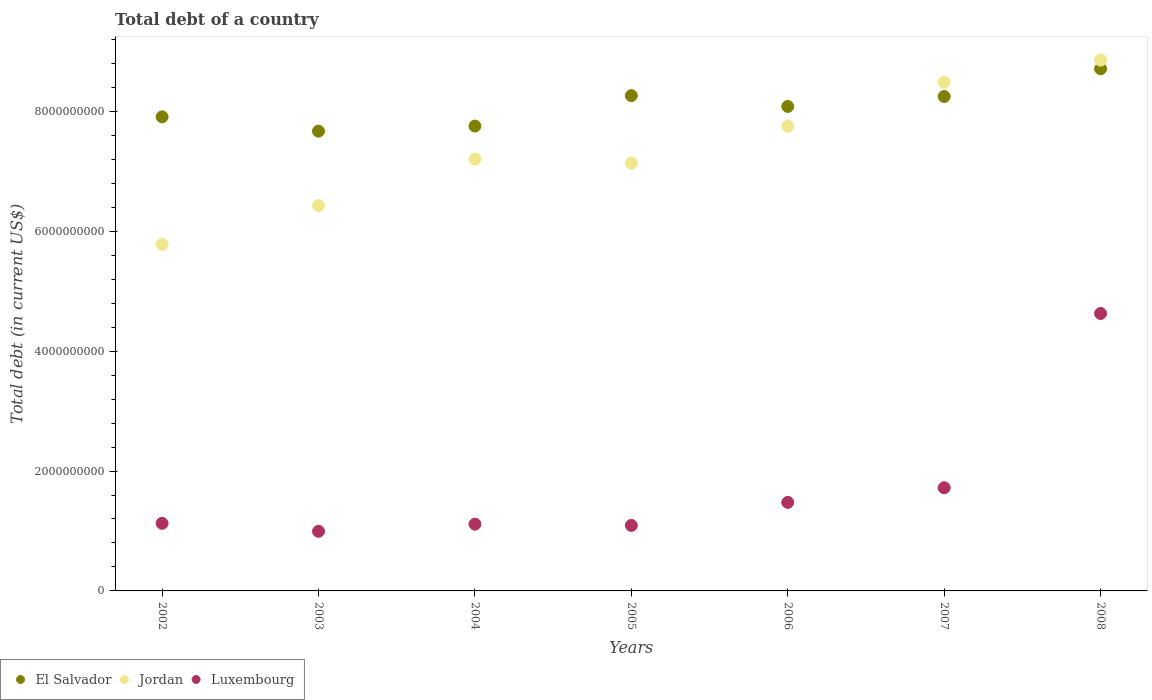How many different coloured dotlines are there?
Keep it short and to the point. 3. Is the number of dotlines equal to the number of legend labels?
Your answer should be compact. Yes. What is the debt in Jordan in 2005?
Offer a terse response. 7.14e+09. Across all years, what is the maximum debt in Jordan?
Give a very brief answer. 8.85e+09. Across all years, what is the minimum debt in Jordan?
Ensure brevity in your answer.  5.78e+09. In which year was the debt in Luxembourg minimum?
Give a very brief answer. 2003. What is the total debt in Jordan in the graph?
Provide a succinct answer. 5.16e+1. What is the difference between the debt in Jordan in 2002 and that in 2005?
Your response must be concise. -1.36e+09. What is the difference between the debt in Luxembourg in 2002 and the debt in Jordan in 2007?
Give a very brief answer. -7.36e+09. What is the average debt in Luxembourg per year?
Offer a terse response. 1.74e+09. In the year 2006, what is the difference between the debt in Luxembourg and debt in El Salvador?
Make the answer very short. -6.61e+09. In how many years, is the debt in Jordan greater than 6000000000 US$?
Give a very brief answer. 6. What is the ratio of the debt in El Salvador in 2005 to that in 2006?
Keep it short and to the point. 1.02. What is the difference between the highest and the second highest debt in Luxembourg?
Make the answer very short. 2.91e+09. What is the difference between the highest and the lowest debt in Jordan?
Give a very brief answer. 3.07e+09. In how many years, is the debt in Jordan greater than the average debt in Jordan taken over all years?
Give a very brief answer. 3. Is it the case that in every year, the sum of the debt in El Salvador and debt in Luxembourg  is greater than the debt in Jordan?
Give a very brief answer. Yes. Does the debt in El Salvador monotonically increase over the years?
Ensure brevity in your answer.  No. Is the debt in El Salvador strictly less than the debt in Jordan over the years?
Your answer should be compact. No. What is the difference between two consecutive major ticks on the Y-axis?
Your answer should be compact. 2.00e+09. Are the values on the major ticks of Y-axis written in scientific E-notation?
Your answer should be very brief. No. Does the graph contain any zero values?
Offer a terse response. No. Does the graph contain grids?
Your response must be concise. No. Where does the legend appear in the graph?
Your answer should be compact. Bottom left. How are the legend labels stacked?
Keep it short and to the point. Horizontal. What is the title of the graph?
Provide a succinct answer. Total debt of a country. What is the label or title of the Y-axis?
Offer a terse response. Total debt (in current US$). What is the Total debt (in current US$) in El Salvador in 2002?
Make the answer very short. 7.91e+09. What is the Total debt (in current US$) of Jordan in 2002?
Offer a very short reply. 5.78e+09. What is the Total debt (in current US$) in Luxembourg in 2002?
Provide a short and direct response. 1.13e+09. What is the Total debt (in current US$) in El Salvador in 2003?
Your answer should be very brief. 7.67e+09. What is the Total debt (in current US$) in Jordan in 2003?
Your response must be concise. 6.43e+09. What is the Total debt (in current US$) of Luxembourg in 2003?
Offer a terse response. 9.94e+08. What is the Total debt (in current US$) of El Salvador in 2004?
Provide a succinct answer. 7.75e+09. What is the Total debt (in current US$) of Jordan in 2004?
Offer a terse response. 7.20e+09. What is the Total debt (in current US$) of Luxembourg in 2004?
Your answer should be very brief. 1.11e+09. What is the Total debt (in current US$) in El Salvador in 2005?
Provide a short and direct response. 8.26e+09. What is the Total debt (in current US$) in Jordan in 2005?
Your response must be concise. 7.14e+09. What is the Total debt (in current US$) of Luxembourg in 2005?
Make the answer very short. 1.09e+09. What is the Total debt (in current US$) in El Salvador in 2006?
Offer a very short reply. 8.08e+09. What is the Total debt (in current US$) of Jordan in 2006?
Your answer should be compact. 7.75e+09. What is the Total debt (in current US$) in Luxembourg in 2006?
Keep it short and to the point. 1.48e+09. What is the Total debt (in current US$) of El Salvador in 2007?
Ensure brevity in your answer.  8.25e+09. What is the Total debt (in current US$) in Jordan in 2007?
Ensure brevity in your answer.  8.49e+09. What is the Total debt (in current US$) in Luxembourg in 2007?
Make the answer very short. 1.72e+09. What is the Total debt (in current US$) in El Salvador in 2008?
Your response must be concise. 8.71e+09. What is the Total debt (in current US$) in Jordan in 2008?
Provide a succinct answer. 8.85e+09. What is the Total debt (in current US$) in Luxembourg in 2008?
Give a very brief answer. 4.63e+09. Across all years, what is the maximum Total debt (in current US$) of El Salvador?
Provide a short and direct response. 8.71e+09. Across all years, what is the maximum Total debt (in current US$) of Jordan?
Offer a terse response. 8.85e+09. Across all years, what is the maximum Total debt (in current US$) of Luxembourg?
Make the answer very short. 4.63e+09. Across all years, what is the minimum Total debt (in current US$) in El Salvador?
Ensure brevity in your answer.  7.67e+09. Across all years, what is the minimum Total debt (in current US$) in Jordan?
Offer a terse response. 5.78e+09. Across all years, what is the minimum Total debt (in current US$) of Luxembourg?
Ensure brevity in your answer.  9.94e+08. What is the total Total debt (in current US$) of El Salvador in the graph?
Offer a very short reply. 5.66e+1. What is the total Total debt (in current US$) of Jordan in the graph?
Provide a succinct answer. 5.16e+1. What is the total Total debt (in current US$) in Luxembourg in the graph?
Offer a terse response. 1.22e+1. What is the difference between the Total debt (in current US$) in El Salvador in 2002 and that in 2003?
Your answer should be compact. 2.39e+08. What is the difference between the Total debt (in current US$) of Jordan in 2002 and that in 2003?
Your answer should be compact. -6.48e+08. What is the difference between the Total debt (in current US$) in Luxembourg in 2002 and that in 2003?
Offer a very short reply. 1.33e+08. What is the difference between the Total debt (in current US$) in El Salvador in 2002 and that in 2004?
Keep it short and to the point. 1.54e+08. What is the difference between the Total debt (in current US$) of Jordan in 2002 and that in 2004?
Provide a short and direct response. -1.42e+09. What is the difference between the Total debt (in current US$) of Luxembourg in 2002 and that in 2004?
Keep it short and to the point. 1.42e+07. What is the difference between the Total debt (in current US$) of El Salvador in 2002 and that in 2005?
Make the answer very short. -3.54e+08. What is the difference between the Total debt (in current US$) in Jordan in 2002 and that in 2005?
Make the answer very short. -1.36e+09. What is the difference between the Total debt (in current US$) in Luxembourg in 2002 and that in 2005?
Offer a terse response. 3.49e+07. What is the difference between the Total debt (in current US$) in El Salvador in 2002 and that in 2006?
Offer a terse response. -1.74e+08. What is the difference between the Total debt (in current US$) of Jordan in 2002 and that in 2006?
Your answer should be compact. -1.97e+09. What is the difference between the Total debt (in current US$) in Luxembourg in 2002 and that in 2006?
Provide a succinct answer. -3.49e+08. What is the difference between the Total debt (in current US$) of El Salvador in 2002 and that in 2007?
Provide a short and direct response. -3.39e+08. What is the difference between the Total debt (in current US$) in Jordan in 2002 and that in 2007?
Your answer should be very brief. -2.71e+09. What is the difference between the Total debt (in current US$) of Luxembourg in 2002 and that in 2007?
Ensure brevity in your answer.  -5.94e+08. What is the difference between the Total debt (in current US$) in El Salvador in 2002 and that in 2008?
Your answer should be very brief. -8.02e+08. What is the difference between the Total debt (in current US$) in Jordan in 2002 and that in 2008?
Your response must be concise. -3.07e+09. What is the difference between the Total debt (in current US$) in Luxembourg in 2002 and that in 2008?
Provide a succinct answer. -3.50e+09. What is the difference between the Total debt (in current US$) in El Salvador in 2003 and that in 2004?
Offer a very short reply. -8.49e+07. What is the difference between the Total debt (in current US$) of Jordan in 2003 and that in 2004?
Keep it short and to the point. -7.75e+08. What is the difference between the Total debt (in current US$) in Luxembourg in 2003 and that in 2004?
Keep it short and to the point. -1.19e+08. What is the difference between the Total debt (in current US$) in El Salvador in 2003 and that in 2005?
Ensure brevity in your answer.  -5.93e+08. What is the difference between the Total debt (in current US$) of Jordan in 2003 and that in 2005?
Your answer should be very brief. -7.08e+08. What is the difference between the Total debt (in current US$) of Luxembourg in 2003 and that in 2005?
Provide a succinct answer. -9.85e+07. What is the difference between the Total debt (in current US$) in El Salvador in 2003 and that in 2006?
Your answer should be very brief. -4.12e+08. What is the difference between the Total debt (in current US$) in Jordan in 2003 and that in 2006?
Your response must be concise. -1.33e+09. What is the difference between the Total debt (in current US$) in Luxembourg in 2003 and that in 2006?
Your answer should be very brief. -4.82e+08. What is the difference between the Total debt (in current US$) in El Salvador in 2003 and that in 2007?
Make the answer very short. -5.78e+08. What is the difference between the Total debt (in current US$) of Jordan in 2003 and that in 2007?
Offer a terse response. -2.06e+09. What is the difference between the Total debt (in current US$) of Luxembourg in 2003 and that in 2007?
Your response must be concise. -7.27e+08. What is the difference between the Total debt (in current US$) of El Salvador in 2003 and that in 2008?
Provide a short and direct response. -1.04e+09. What is the difference between the Total debt (in current US$) in Jordan in 2003 and that in 2008?
Your answer should be compact. -2.43e+09. What is the difference between the Total debt (in current US$) in Luxembourg in 2003 and that in 2008?
Make the answer very short. -3.63e+09. What is the difference between the Total debt (in current US$) of El Salvador in 2004 and that in 2005?
Offer a very short reply. -5.08e+08. What is the difference between the Total debt (in current US$) in Jordan in 2004 and that in 2005?
Your response must be concise. 6.67e+07. What is the difference between the Total debt (in current US$) of Luxembourg in 2004 and that in 2005?
Your answer should be very brief. 2.07e+07. What is the difference between the Total debt (in current US$) in El Salvador in 2004 and that in 2006?
Make the answer very short. -3.27e+08. What is the difference between the Total debt (in current US$) of Jordan in 2004 and that in 2006?
Offer a terse response. -5.50e+08. What is the difference between the Total debt (in current US$) in Luxembourg in 2004 and that in 2006?
Make the answer very short. -3.63e+08. What is the difference between the Total debt (in current US$) of El Salvador in 2004 and that in 2007?
Ensure brevity in your answer.  -4.93e+08. What is the difference between the Total debt (in current US$) in Jordan in 2004 and that in 2007?
Offer a very short reply. -1.28e+09. What is the difference between the Total debt (in current US$) of Luxembourg in 2004 and that in 2007?
Your response must be concise. -6.08e+08. What is the difference between the Total debt (in current US$) of El Salvador in 2004 and that in 2008?
Offer a very short reply. -9.56e+08. What is the difference between the Total debt (in current US$) in Jordan in 2004 and that in 2008?
Keep it short and to the point. -1.65e+09. What is the difference between the Total debt (in current US$) of Luxembourg in 2004 and that in 2008?
Your response must be concise. -3.51e+09. What is the difference between the Total debt (in current US$) in El Salvador in 2005 and that in 2006?
Your answer should be compact. 1.81e+08. What is the difference between the Total debt (in current US$) in Jordan in 2005 and that in 2006?
Your response must be concise. -6.17e+08. What is the difference between the Total debt (in current US$) in Luxembourg in 2005 and that in 2006?
Provide a short and direct response. -3.84e+08. What is the difference between the Total debt (in current US$) in El Salvador in 2005 and that in 2007?
Offer a terse response. 1.49e+07. What is the difference between the Total debt (in current US$) in Jordan in 2005 and that in 2007?
Give a very brief answer. -1.35e+09. What is the difference between the Total debt (in current US$) in Luxembourg in 2005 and that in 2007?
Offer a terse response. -6.28e+08. What is the difference between the Total debt (in current US$) of El Salvador in 2005 and that in 2008?
Keep it short and to the point. -4.48e+08. What is the difference between the Total debt (in current US$) of Jordan in 2005 and that in 2008?
Ensure brevity in your answer.  -1.72e+09. What is the difference between the Total debt (in current US$) of Luxembourg in 2005 and that in 2008?
Your response must be concise. -3.54e+09. What is the difference between the Total debt (in current US$) in El Salvador in 2006 and that in 2007?
Offer a very short reply. -1.66e+08. What is the difference between the Total debt (in current US$) in Jordan in 2006 and that in 2007?
Offer a very short reply. -7.34e+08. What is the difference between the Total debt (in current US$) of Luxembourg in 2006 and that in 2007?
Offer a terse response. -2.44e+08. What is the difference between the Total debt (in current US$) in El Salvador in 2006 and that in 2008?
Provide a succinct answer. -6.29e+08. What is the difference between the Total debt (in current US$) in Jordan in 2006 and that in 2008?
Provide a succinct answer. -1.10e+09. What is the difference between the Total debt (in current US$) of Luxembourg in 2006 and that in 2008?
Your answer should be compact. -3.15e+09. What is the difference between the Total debt (in current US$) of El Salvador in 2007 and that in 2008?
Ensure brevity in your answer.  -4.63e+08. What is the difference between the Total debt (in current US$) of Jordan in 2007 and that in 2008?
Your answer should be compact. -3.68e+08. What is the difference between the Total debt (in current US$) in Luxembourg in 2007 and that in 2008?
Offer a terse response. -2.91e+09. What is the difference between the Total debt (in current US$) of El Salvador in 2002 and the Total debt (in current US$) of Jordan in 2003?
Ensure brevity in your answer.  1.48e+09. What is the difference between the Total debt (in current US$) of El Salvador in 2002 and the Total debt (in current US$) of Luxembourg in 2003?
Make the answer very short. 6.91e+09. What is the difference between the Total debt (in current US$) in Jordan in 2002 and the Total debt (in current US$) in Luxembourg in 2003?
Give a very brief answer. 4.79e+09. What is the difference between the Total debt (in current US$) of El Salvador in 2002 and the Total debt (in current US$) of Jordan in 2004?
Offer a very short reply. 7.06e+08. What is the difference between the Total debt (in current US$) in El Salvador in 2002 and the Total debt (in current US$) in Luxembourg in 2004?
Offer a terse response. 6.79e+09. What is the difference between the Total debt (in current US$) of Jordan in 2002 and the Total debt (in current US$) of Luxembourg in 2004?
Your answer should be compact. 4.67e+09. What is the difference between the Total debt (in current US$) of El Salvador in 2002 and the Total debt (in current US$) of Jordan in 2005?
Keep it short and to the point. 7.72e+08. What is the difference between the Total debt (in current US$) in El Salvador in 2002 and the Total debt (in current US$) in Luxembourg in 2005?
Your answer should be very brief. 6.82e+09. What is the difference between the Total debt (in current US$) in Jordan in 2002 and the Total debt (in current US$) in Luxembourg in 2005?
Ensure brevity in your answer.  4.69e+09. What is the difference between the Total debt (in current US$) of El Salvador in 2002 and the Total debt (in current US$) of Jordan in 2006?
Provide a succinct answer. 1.55e+08. What is the difference between the Total debt (in current US$) in El Salvador in 2002 and the Total debt (in current US$) in Luxembourg in 2006?
Keep it short and to the point. 6.43e+09. What is the difference between the Total debt (in current US$) of Jordan in 2002 and the Total debt (in current US$) of Luxembourg in 2006?
Give a very brief answer. 4.30e+09. What is the difference between the Total debt (in current US$) in El Salvador in 2002 and the Total debt (in current US$) in Jordan in 2007?
Offer a very short reply. -5.79e+08. What is the difference between the Total debt (in current US$) in El Salvador in 2002 and the Total debt (in current US$) in Luxembourg in 2007?
Offer a very short reply. 6.19e+09. What is the difference between the Total debt (in current US$) in Jordan in 2002 and the Total debt (in current US$) in Luxembourg in 2007?
Offer a terse response. 4.06e+09. What is the difference between the Total debt (in current US$) of El Salvador in 2002 and the Total debt (in current US$) of Jordan in 2008?
Your answer should be very brief. -9.46e+08. What is the difference between the Total debt (in current US$) of El Salvador in 2002 and the Total debt (in current US$) of Luxembourg in 2008?
Offer a very short reply. 3.28e+09. What is the difference between the Total debt (in current US$) of Jordan in 2002 and the Total debt (in current US$) of Luxembourg in 2008?
Keep it short and to the point. 1.15e+09. What is the difference between the Total debt (in current US$) of El Salvador in 2003 and the Total debt (in current US$) of Jordan in 2004?
Offer a very short reply. 4.67e+08. What is the difference between the Total debt (in current US$) in El Salvador in 2003 and the Total debt (in current US$) in Luxembourg in 2004?
Give a very brief answer. 6.56e+09. What is the difference between the Total debt (in current US$) in Jordan in 2003 and the Total debt (in current US$) in Luxembourg in 2004?
Give a very brief answer. 5.31e+09. What is the difference between the Total debt (in current US$) of El Salvador in 2003 and the Total debt (in current US$) of Jordan in 2005?
Offer a very short reply. 5.34e+08. What is the difference between the Total debt (in current US$) in El Salvador in 2003 and the Total debt (in current US$) in Luxembourg in 2005?
Ensure brevity in your answer.  6.58e+09. What is the difference between the Total debt (in current US$) of Jordan in 2003 and the Total debt (in current US$) of Luxembourg in 2005?
Ensure brevity in your answer.  5.33e+09. What is the difference between the Total debt (in current US$) of El Salvador in 2003 and the Total debt (in current US$) of Jordan in 2006?
Keep it short and to the point. -8.33e+07. What is the difference between the Total debt (in current US$) in El Salvador in 2003 and the Total debt (in current US$) in Luxembourg in 2006?
Provide a short and direct response. 6.19e+09. What is the difference between the Total debt (in current US$) in Jordan in 2003 and the Total debt (in current US$) in Luxembourg in 2006?
Offer a terse response. 4.95e+09. What is the difference between the Total debt (in current US$) of El Salvador in 2003 and the Total debt (in current US$) of Jordan in 2007?
Your answer should be very brief. -8.17e+08. What is the difference between the Total debt (in current US$) in El Salvador in 2003 and the Total debt (in current US$) in Luxembourg in 2007?
Make the answer very short. 5.95e+09. What is the difference between the Total debt (in current US$) in Jordan in 2003 and the Total debt (in current US$) in Luxembourg in 2007?
Provide a succinct answer. 4.71e+09. What is the difference between the Total debt (in current US$) in El Salvador in 2003 and the Total debt (in current US$) in Jordan in 2008?
Your answer should be very brief. -1.18e+09. What is the difference between the Total debt (in current US$) of El Salvador in 2003 and the Total debt (in current US$) of Luxembourg in 2008?
Ensure brevity in your answer.  3.04e+09. What is the difference between the Total debt (in current US$) of Jordan in 2003 and the Total debt (in current US$) of Luxembourg in 2008?
Your answer should be compact. 1.80e+09. What is the difference between the Total debt (in current US$) of El Salvador in 2004 and the Total debt (in current US$) of Jordan in 2005?
Your answer should be compact. 6.19e+08. What is the difference between the Total debt (in current US$) of El Salvador in 2004 and the Total debt (in current US$) of Luxembourg in 2005?
Keep it short and to the point. 6.66e+09. What is the difference between the Total debt (in current US$) of Jordan in 2004 and the Total debt (in current US$) of Luxembourg in 2005?
Ensure brevity in your answer.  6.11e+09. What is the difference between the Total debt (in current US$) in El Salvador in 2004 and the Total debt (in current US$) in Jordan in 2006?
Ensure brevity in your answer.  1.60e+06. What is the difference between the Total debt (in current US$) of El Salvador in 2004 and the Total debt (in current US$) of Luxembourg in 2006?
Provide a short and direct response. 6.28e+09. What is the difference between the Total debt (in current US$) in Jordan in 2004 and the Total debt (in current US$) in Luxembourg in 2006?
Your answer should be very brief. 5.73e+09. What is the difference between the Total debt (in current US$) of El Salvador in 2004 and the Total debt (in current US$) of Jordan in 2007?
Your response must be concise. -7.32e+08. What is the difference between the Total debt (in current US$) of El Salvador in 2004 and the Total debt (in current US$) of Luxembourg in 2007?
Your answer should be very brief. 6.03e+09. What is the difference between the Total debt (in current US$) of Jordan in 2004 and the Total debt (in current US$) of Luxembourg in 2007?
Offer a very short reply. 5.48e+09. What is the difference between the Total debt (in current US$) of El Salvador in 2004 and the Total debt (in current US$) of Jordan in 2008?
Give a very brief answer. -1.10e+09. What is the difference between the Total debt (in current US$) in El Salvador in 2004 and the Total debt (in current US$) in Luxembourg in 2008?
Make the answer very short. 3.13e+09. What is the difference between the Total debt (in current US$) of Jordan in 2004 and the Total debt (in current US$) of Luxembourg in 2008?
Offer a terse response. 2.57e+09. What is the difference between the Total debt (in current US$) of El Salvador in 2005 and the Total debt (in current US$) of Jordan in 2006?
Provide a short and direct response. 5.10e+08. What is the difference between the Total debt (in current US$) of El Salvador in 2005 and the Total debt (in current US$) of Luxembourg in 2006?
Ensure brevity in your answer.  6.79e+09. What is the difference between the Total debt (in current US$) in Jordan in 2005 and the Total debt (in current US$) in Luxembourg in 2006?
Provide a succinct answer. 5.66e+09. What is the difference between the Total debt (in current US$) in El Salvador in 2005 and the Total debt (in current US$) in Jordan in 2007?
Provide a short and direct response. -2.24e+08. What is the difference between the Total debt (in current US$) of El Salvador in 2005 and the Total debt (in current US$) of Luxembourg in 2007?
Provide a succinct answer. 6.54e+09. What is the difference between the Total debt (in current US$) of Jordan in 2005 and the Total debt (in current US$) of Luxembourg in 2007?
Provide a short and direct response. 5.41e+09. What is the difference between the Total debt (in current US$) of El Salvador in 2005 and the Total debt (in current US$) of Jordan in 2008?
Your response must be concise. -5.92e+08. What is the difference between the Total debt (in current US$) in El Salvador in 2005 and the Total debt (in current US$) in Luxembourg in 2008?
Provide a succinct answer. 3.63e+09. What is the difference between the Total debt (in current US$) in Jordan in 2005 and the Total debt (in current US$) in Luxembourg in 2008?
Provide a short and direct response. 2.51e+09. What is the difference between the Total debt (in current US$) in El Salvador in 2006 and the Total debt (in current US$) in Jordan in 2007?
Offer a terse response. -4.05e+08. What is the difference between the Total debt (in current US$) of El Salvador in 2006 and the Total debt (in current US$) of Luxembourg in 2007?
Provide a short and direct response. 6.36e+09. What is the difference between the Total debt (in current US$) in Jordan in 2006 and the Total debt (in current US$) in Luxembourg in 2007?
Your answer should be compact. 6.03e+09. What is the difference between the Total debt (in current US$) of El Salvador in 2006 and the Total debt (in current US$) of Jordan in 2008?
Give a very brief answer. -7.73e+08. What is the difference between the Total debt (in current US$) in El Salvador in 2006 and the Total debt (in current US$) in Luxembourg in 2008?
Your answer should be compact. 3.45e+09. What is the difference between the Total debt (in current US$) of Jordan in 2006 and the Total debt (in current US$) of Luxembourg in 2008?
Offer a very short reply. 3.12e+09. What is the difference between the Total debt (in current US$) in El Salvador in 2007 and the Total debt (in current US$) in Jordan in 2008?
Offer a terse response. -6.07e+08. What is the difference between the Total debt (in current US$) in El Salvador in 2007 and the Total debt (in current US$) in Luxembourg in 2008?
Offer a terse response. 3.62e+09. What is the difference between the Total debt (in current US$) in Jordan in 2007 and the Total debt (in current US$) in Luxembourg in 2008?
Give a very brief answer. 3.86e+09. What is the average Total debt (in current US$) in El Salvador per year?
Offer a terse response. 8.09e+09. What is the average Total debt (in current US$) in Jordan per year?
Provide a short and direct response. 7.38e+09. What is the average Total debt (in current US$) in Luxembourg per year?
Offer a terse response. 1.74e+09. In the year 2002, what is the difference between the Total debt (in current US$) in El Salvador and Total debt (in current US$) in Jordan?
Provide a short and direct response. 2.13e+09. In the year 2002, what is the difference between the Total debt (in current US$) in El Salvador and Total debt (in current US$) in Luxembourg?
Provide a short and direct response. 6.78e+09. In the year 2002, what is the difference between the Total debt (in current US$) of Jordan and Total debt (in current US$) of Luxembourg?
Offer a very short reply. 4.65e+09. In the year 2003, what is the difference between the Total debt (in current US$) in El Salvador and Total debt (in current US$) in Jordan?
Your response must be concise. 1.24e+09. In the year 2003, what is the difference between the Total debt (in current US$) of El Salvador and Total debt (in current US$) of Luxembourg?
Provide a short and direct response. 6.68e+09. In the year 2003, what is the difference between the Total debt (in current US$) in Jordan and Total debt (in current US$) in Luxembourg?
Offer a terse response. 5.43e+09. In the year 2004, what is the difference between the Total debt (in current US$) of El Salvador and Total debt (in current US$) of Jordan?
Your answer should be compact. 5.52e+08. In the year 2004, what is the difference between the Total debt (in current US$) in El Salvador and Total debt (in current US$) in Luxembourg?
Keep it short and to the point. 6.64e+09. In the year 2004, what is the difference between the Total debt (in current US$) of Jordan and Total debt (in current US$) of Luxembourg?
Provide a succinct answer. 6.09e+09. In the year 2005, what is the difference between the Total debt (in current US$) in El Salvador and Total debt (in current US$) in Jordan?
Offer a terse response. 1.13e+09. In the year 2005, what is the difference between the Total debt (in current US$) of El Salvador and Total debt (in current US$) of Luxembourg?
Offer a terse response. 7.17e+09. In the year 2005, what is the difference between the Total debt (in current US$) in Jordan and Total debt (in current US$) in Luxembourg?
Provide a succinct answer. 6.04e+09. In the year 2006, what is the difference between the Total debt (in current US$) of El Salvador and Total debt (in current US$) of Jordan?
Your answer should be very brief. 3.29e+08. In the year 2006, what is the difference between the Total debt (in current US$) of El Salvador and Total debt (in current US$) of Luxembourg?
Your answer should be very brief. 6.61e+09. In the year 2006, what is the difference between the Total debt (in current US$) of Jordan and Total debt (in current US$) of Luxembourg?
Offer a terse response. 6.28e+09. In the year 2007, what is the difference between the Total debt (in current US$) in El Salvador and Total debt (in current US$) in Jordan?
Your answer should be compact. -2.39e+08. In the year 2007, what is the difference between the Total debt (in current US$) in El Salvador and Total debt (in current US$) in Luxembourg?
Your answer should be compact. 6.53e+09. In the year 2007, what is the difference between the Total debt (in current US$) of Jordan and Total debt (in current US$) of Luxembourg?
Ensure brevity in your answer.  6.77e+09. In the year 2008, what is the difference between the Total debt (in current US$) in El Salvador and Total debt (in current US$) in Jordan?
Your answer should be compact. -1.44e+08. In the year 2008, what is the difference between the Total debt (in current US$) of El Salvador and Total debt (in current US$) of Luxembourg?
Offer a terse response. 4.08e+09. In the year 2008, what is the difference between the Total debt (in current US$) in Jordan and Total debt (in current US$) in Luxembourg?
Offer a terse response. 4.23e+09. What is the ratio of the Total debt (in current US$) in El Salvador in 2002 to that in 2003?
Give a very brief answer. 1.03. What is the ratio of the Total debt (in current US$) in Jordan in 2002 to that in 2003?
Keep it short and to the point. 0.9. What is the ratio of the Total debt (in current US$) of Luxembourg in 2002 to that in 2003?
Offer a very short reply. 1.13. What is the ratio of the Total debt (in current US$) of El Salvador in 2002 to that in 2004?
Give a very brief answer. 1.02. What is the ratio of the Total debt (in current US$) of Jordan in 2002 to that in 2004?
Provide a short and direct response. 0.8. What is the ratio of the Total debt (in current US$) of Luxembourg in 2002 to that in 2004?
Make the answer very short. 1.01. What is the ratio of the Total debt (in current US$) of El Salvador in 2002 to that in 2005?
Provide a short and direct response. 0.96. What is the ratio of the Total debt (in current US$) in Jordan in 2002 to that in 2005?
Your response must be concise. 0.81. What is the ratio of the Total debt (in current US$) in Luxembourg in 2002 to that in 2005?
Offer a very short reply. 1.03. What is the ratio of the Total debt (in current US$) of El Salvador in 2002 to that in 2006?
Keep it short and to the point. 0.98. What is the ratio of the Total debt (in current US$) in Jordan in 2002 to that in 2006?
Your answer should be compact. 0.75. What is the ratio of the Total debt (in current US$) of Luxembourg in 2002 to that in 2006?
Your answer should be compact. 0.76. What is the ratio of the Total debt (in current US$) in El Salvador in 2002 to that in 2007?
Your answer should be very brief. 0.96. What is the ratio of the Total debt (in current US$) of Jordan in 2002 to that in 2007?
Your response must be concise. 0.68. What is the ratio of the Total debt (in current US$) in Luxembourg in 2002 to that in 2007?
Offer a very short reply. 0.66. What is the ratio of the Total debt (in current US$) in El Salvador in 2002 to that in 2008?
Your answer should be compact. 0.91. What is the ratio of the Total debt (in current US$) in Jordan in 2002 to that in 2008?
Make the answer very short. 0.65. What is the ratio of the Total debt (in current US$) of Luxembourg in 2002 to that in 2008?
Offer a terse response. 0.24. What is the ratio of the Total debt (in current US$) in Jordan in 2003 to that in 2004?
Give a very brief answer. 0.89. What is the ratio of the Total debt (in current US$) in Luxembourg in 2003 to that in 2004?
Offer a terse response. 0.89. What is the ratio of the Total debt (in current US$) in El Salvador in 2003 to that in 2005?
Ensure brevity in your answer.  0.93. What is the ratio of the Total debt (in current US$) of Jordan in 2003 to that in 2005?
Offer a terse response. 0.9. What is the ratio of the Total debt (in current US$) in Luxembourg in 2003 to that in 2005?
Your response must be concise. 0.91. What is the ratio of the Total debt (in current US$) in El Salvador in 2003 to that in 2006?
Offer a terse response. 0.95. What is the ratio of the Total debt (in current US$) of Jordan in 2003 to that in 2006?
Your response must be concise. 0.83. What is the ratio of the Total debt (in current US$) of Luxembourg in 2003 to that in 2006?
Your response must be concise. 0.67. What is the ratio of the Total debt (in current US$) in El Salvador in 2003 to that in 2007?
Make the answer very short. 0.93. What is the ratio of the Total debt (in current US$) of Jordan in 2003 to that in 2007?
Keep it short and to the point. 0.76. What is the ratio of the Total debt (in current US$) in Luxembourg in 2003 to that in 2007?
Give a very brief answer. 0.58. What is the ratio of the Total debt (in current US$) of El Salvador in 2003 to that in 2008?
Your answer should be compact. 0.88. What is the ratio of the Total debt (in current US$) in Jordan in 2003 to that in 2008?
Your response must be concise. 0.73. What is the ratio of the Total debt (in current US$) in Luxembourg in 2003 to that in 2008?
Make the answer very short. 0.21. What is the ratio of the Total debt (in current US$) of El Salvador in 2004 to that in 2005?
Keep it short and to the point. 0.94. What is the ratio of the Total debt (in current US$) in Jordan in 2004 to that in 2005?
Make the answer very short. 1.01. What is the ratio of the Total debt (in current US$) of Luxembourg in 2004 to that in 2005?
Make the answer very short. 1.02. What is the ratio of the Total debt (in current US$) in El Salvador in 2004 to that in 2006?
Your response must be concise. 0.96. What is the ratio of the Total debt (in current US$) of Jordan in 2004 to that in 2006?
Make the answer very short. 0.93. What is the ratio of the Total debt (in current US$) in Luxembourg in 2004 to that in 2006?
Provide a succinct answer. 0.75. What is the ratio of the Total debt (in current US$) in El Salvador in 2004 to that in 2007?
Offer a terse response. 0.94. What is the ratio of the Total debt (in current US$) in Jordan in 2004 to that in 2007?
Your answer should be compact. 0.85. What is the ratio of the Total debt (in current US$) of Luxembourg in 2004 to that in 2007?
Offer a very short reply. 0.65. What is the ratio of the Total debt (in current US$) of El Salvador in 2004 to that in 2008?
Provide a short and direct response. 0.89. What is the ratio of the Total debt (in current US$) of Jordan in 2004 to that in 2008?
Ensure brevity in your answer.  0.81. What is the ratio of the Total debt (in current US$) in Luxembourg in 2004 to that in 2008?
Provide a succinct answer. 0.24. What is the ratio of the Total debt (in current US$) of El Salvador in 2005 to that in 2006?
Your answer should be compact. 1.02. What is the ratio of the Total debt (in current US$) of Jordan in 2005 to that in 2006?
Offer a terse response. 0.92. What is the ratio of the Total debt (in current US$) of Luxembourg in 2005 to that in 2006?
Make the answer very short. 0.74. What is the ratio of the Total debt (in current US$) of El Salvador in 2005 to that in 2007?
Offer a very short reply. 1. What is the ratio of the Total debt (in current US$) in Jordan in 2005 to that in 2007?
Your answer should be very brief. 0.84. What is the ratio of the Total debt (in current US$) of Luxembourg in 2005 to that in 2007?
Keep it short and to the point. 0.63. What is the ratio of the Total debt (in current US$) in El Salvador in 2005 to that in 2008?
Offer a terse response. 0.95. What is the ratio of the Total debt (in current US$) of Jordan in 2005 to that in 2008?
Make the answer very short. 0.81. What is the ratio of the Total debt (in current US$) of Luxembourg in 2005 to that in 2008?
Offer a terse response. 0.24. What is the ratio of the Total debt (in current US$) of El Salvador in 2006 to that in 2007?
Ensure brevity in your answer.  0.98. What is the ratio of the Total debt (in current US$) of Jordan in 2006 to that in 2007?
Your response must be concise. 0.91. What is the ratio of the Total debt (in current US$) of Luxembourg in 2006 to that in 2007?
Provide a short and direct response. 0.86. What is the ratio of the Total debt (in current US$) of El Salvador in 2006 to that in 2008?
Offer a very short reply. 0.93. What is the ratio of the Total debt (in current US$) in Jordan in 2006 to that in 2008?
Offer a terse response. 0.88. What is the ratio of the Total debt (in current US$) of Luxembourg in 2006 to that in 2008?
Your response must be concise. 0.32. What is the ratio of the Total debt (in current US$) in El Salvador in 2007 to that in 2008?
Your response must be concise. 0.95. What is the ratio of the Total debt (in current US$) in Jordan in 2007 to that in 2008?
Provide a short and direct response. 0.96. What is the ratio of the Total debt (in current US$) in Luxembourg in 2007 to that in 2008?
Provide a succinct answer. 0.37. What is the difference between the highest and the second highest Total debt (in current US$) of El Salvador?
Your response must be concise. 4.48e+08. What is the difference between the highest and the second highest Total debt (in current US$) of Jordan?
Provide a succinct answer. 3.68e+08. What is the difference between the highest and the second highest Total debt (in current US$) in Luxembourg?
Make the answer very short. 2.91e+09. What is the difference between the highest and the lowest Total debt (in current US$) in El Salvador?
Provide a short and direct response. 1.04e+09. What is the difference between the highest and the lowest Total debt (in current US$) of Jordan?
Your answer should be compact. 3.07e+09. What is the difference between the highest and the lowest Total debt (in current US$) in Luxembourg?
Your answer should be very brief. 3.63e+09. 